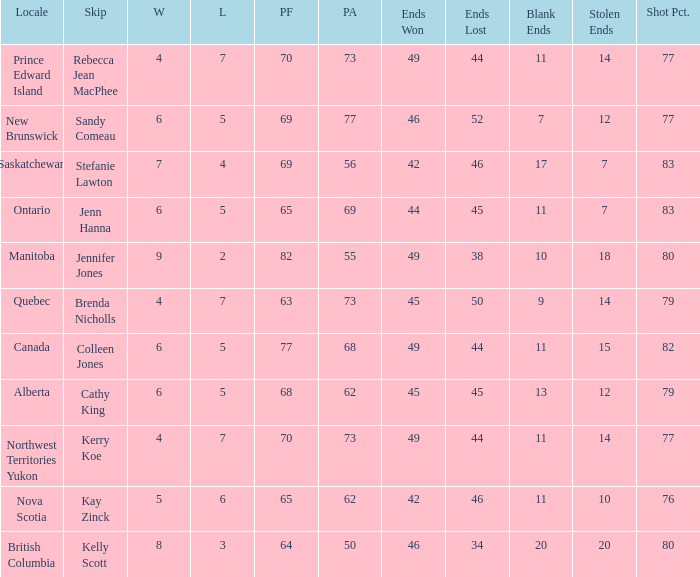What is the minimum PA when ends lost is 45? 62.0. 